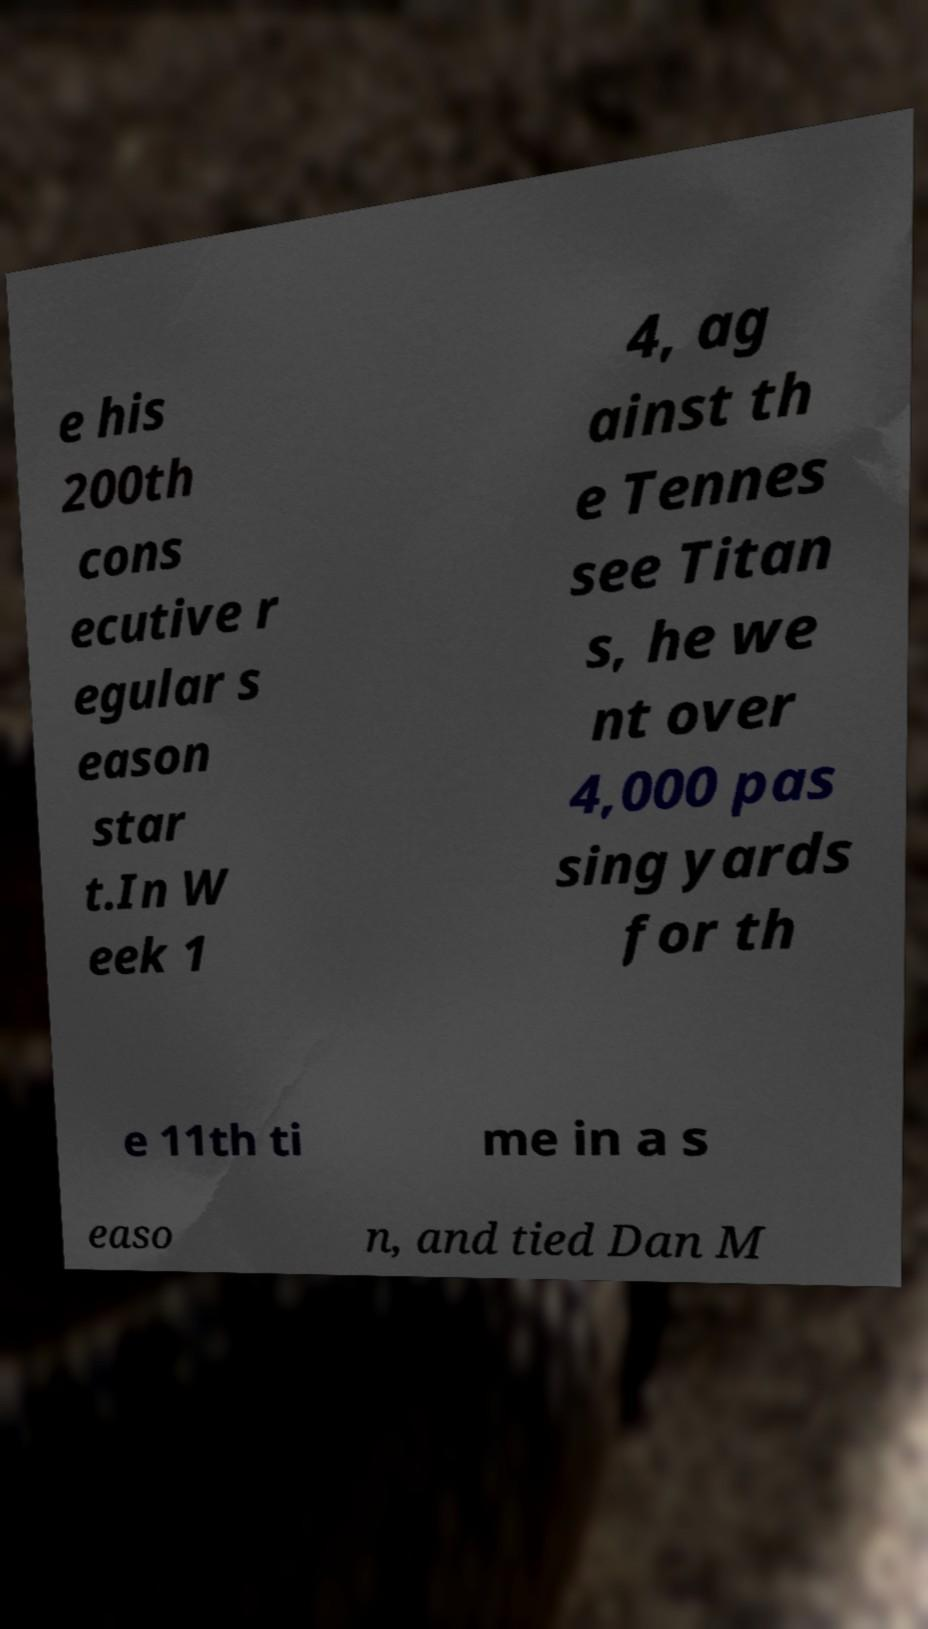Please identify and transcribe the text found in this image. e his 200th cons ecutive r egular s eason star t.In W eek 1 4, ag ainst th e Tennes see Titan s, he we nt over 4,000 pas sing yards for th e 11th ti me in a s easo n, and tied Dan M 